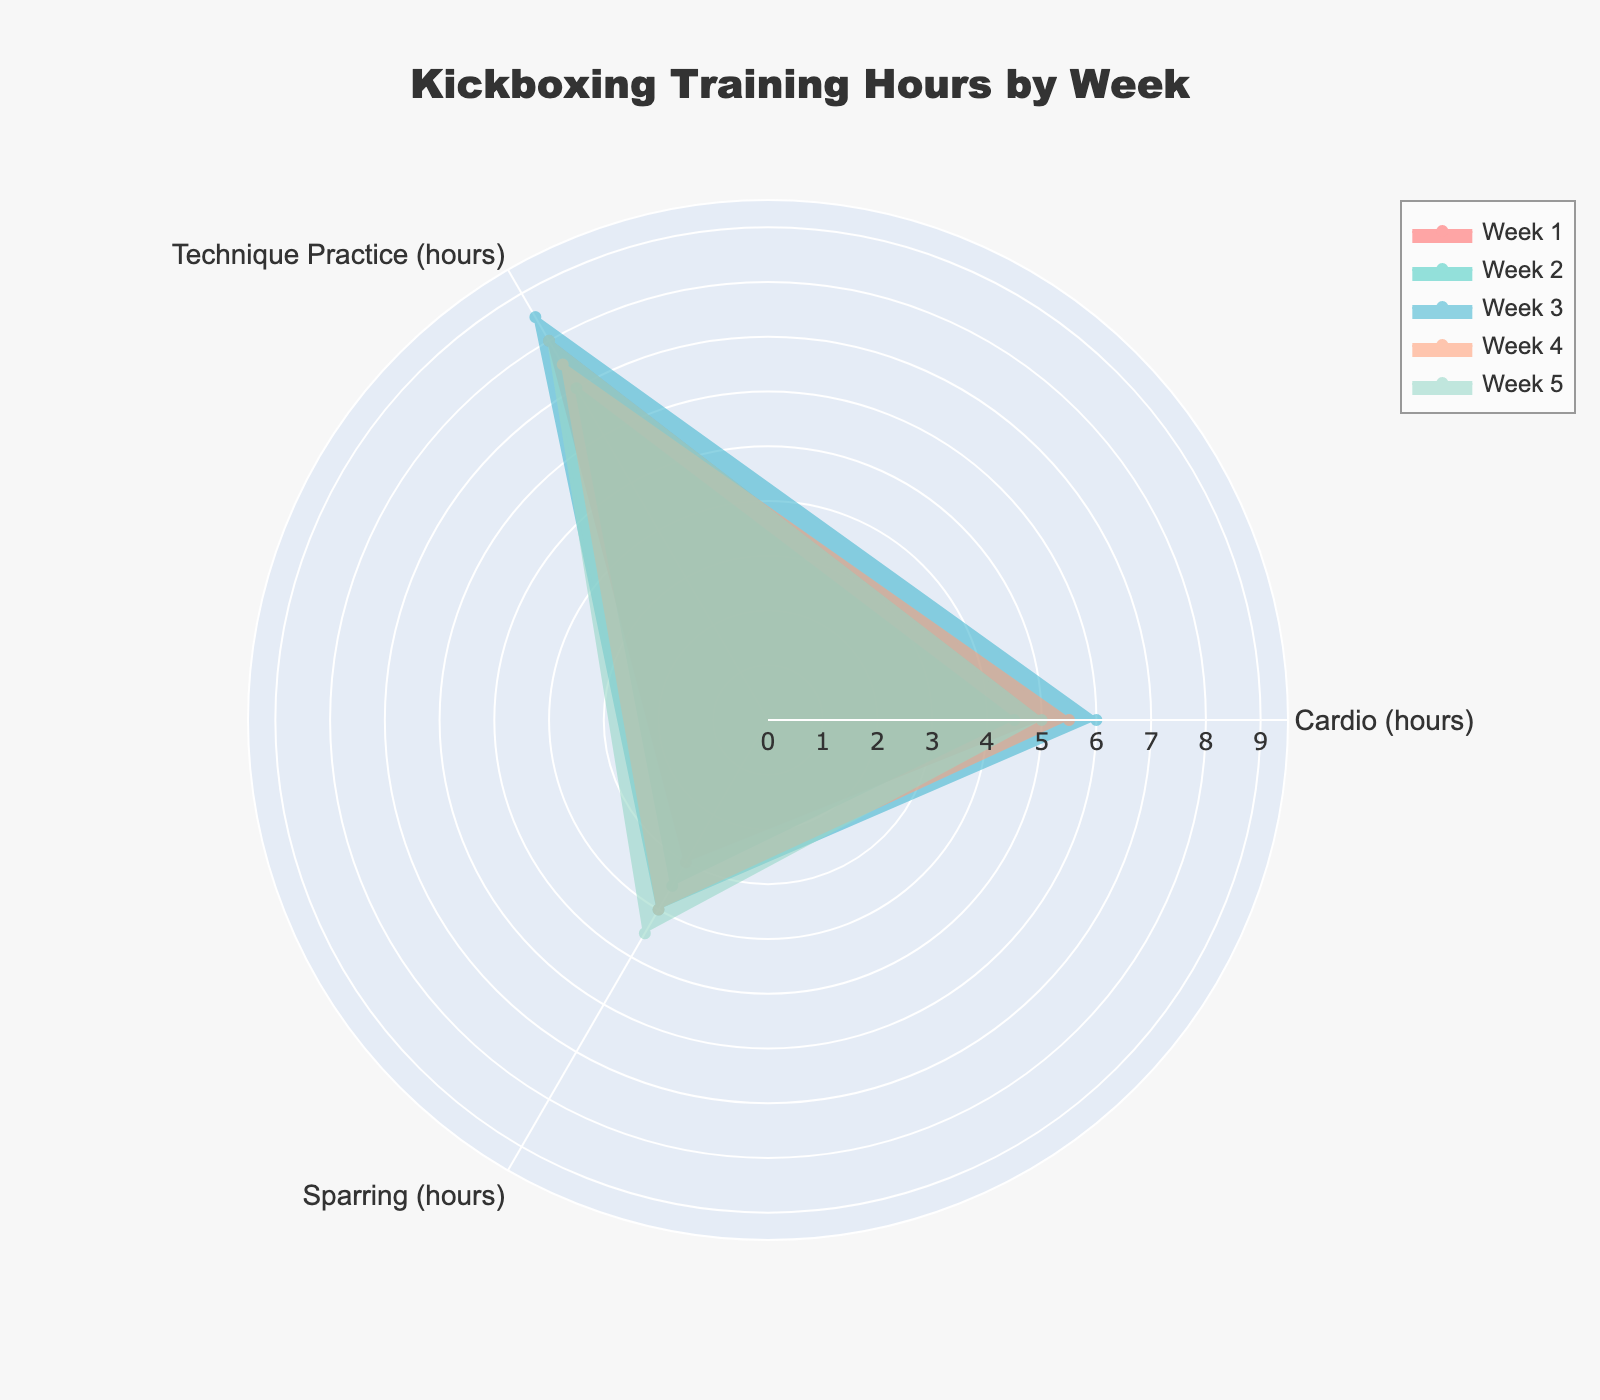What are the three training activities shown on the chart? The radar chart's axes represent different training activities. Observing the chart, we can identify the labels of these axes.
Answer: Cardio, Technique Practice, Sparring Which week had the highest number of hours spent on technique practice? By looking at the radar chart lines for technique practice, we can observe which week reaches the highest value on that axis. Comparing all weeks, Week 3 reaches the highest point.
Answer: Week 3 How many hours were spent on cardio in Week 2? We find the line corresponding to Week 2 and check the value on the cardio axis. The value for cardio in Week 2 is 4.5 hours.
Answer: 4.5 In which week did sparring time exceed cardio time? We need to compare the values of cardio and sparring for each week. Week 4 (sparring 4 hours vs. cardio 5.5 hours) and Week 5 (sparring 4.5 hours vs. cardio 5 hours) don't qualify, but Week 3 does (sparring 4 hours vs. cardio 6 hours). None of the weeks met the condition.
Answer: None What is the average number of hours spent on sparring over the five weeks? Calculate the average by summing the sparring hours (3 + 3.5 + 4 + 4 + 4.5 = 19) and dividing by the number of weeks (5).
Answer: 3.8 Which week has the most balanced training distribution across all activities? A balanced training distribution means the values on the radar chart form a shape close to a regular polygon. By visually inspecting the chart, Week 4 appears balanced across activities with the similar distances from the center.
Answer: Week 4 How does Week 1's training in technique practice compare to Week 5's? We compare the values for technique practice between Week 1 and Week 5 on the radar chart. Week 1 has 8 hours while Week 5 has the same.
Answer: Equal Which week has the overall highest total training hours? Sum up the training hours for each week and compare. Week 4 has 5.5 + 7.5 + 4 = 17 hours, which is the highest.
Answer: Week 4 